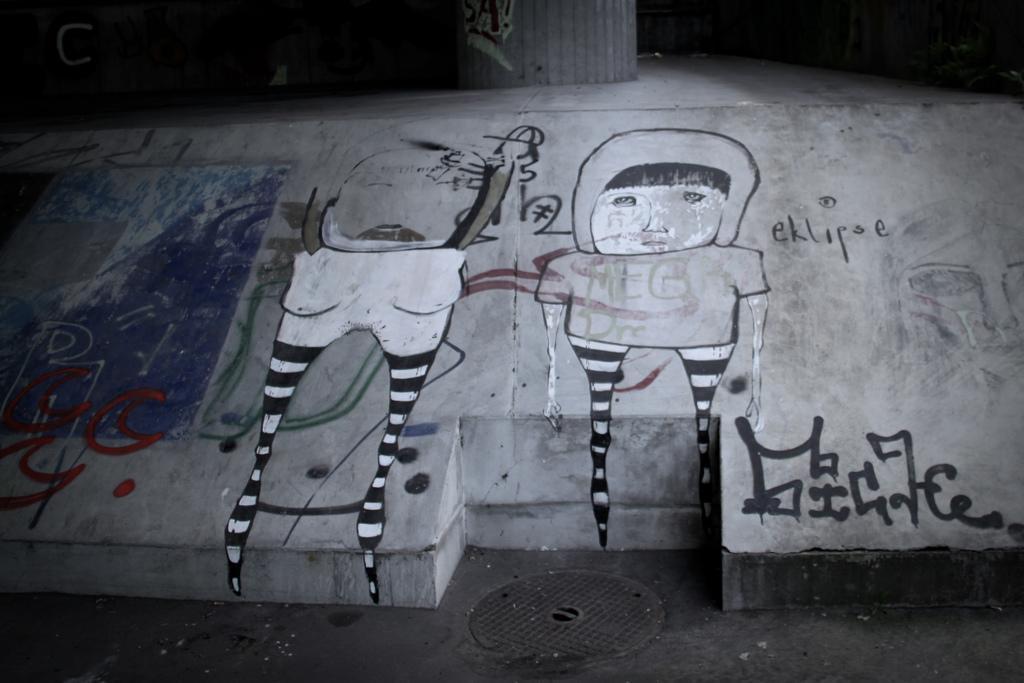Could you give a brief overview of what you see in this image? This picture shows painting on the wall and we see a text 